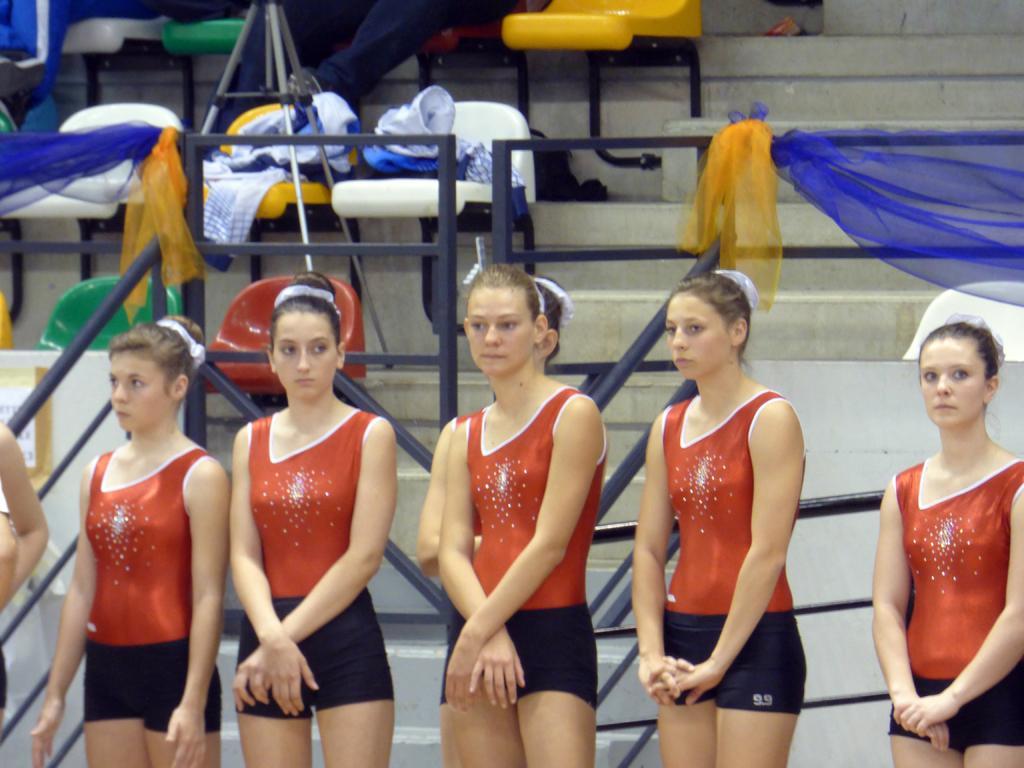Can you describe this image briefly? In this image there are group of girls who are wearing the red dress and black short are standing by holding their hands. In the background it looks a stadium in which there are so many seats. There is a fence around the seats. There are net clothes which are tied to the poles. In the middle there is a tripod. On the chairs there are clothes. 